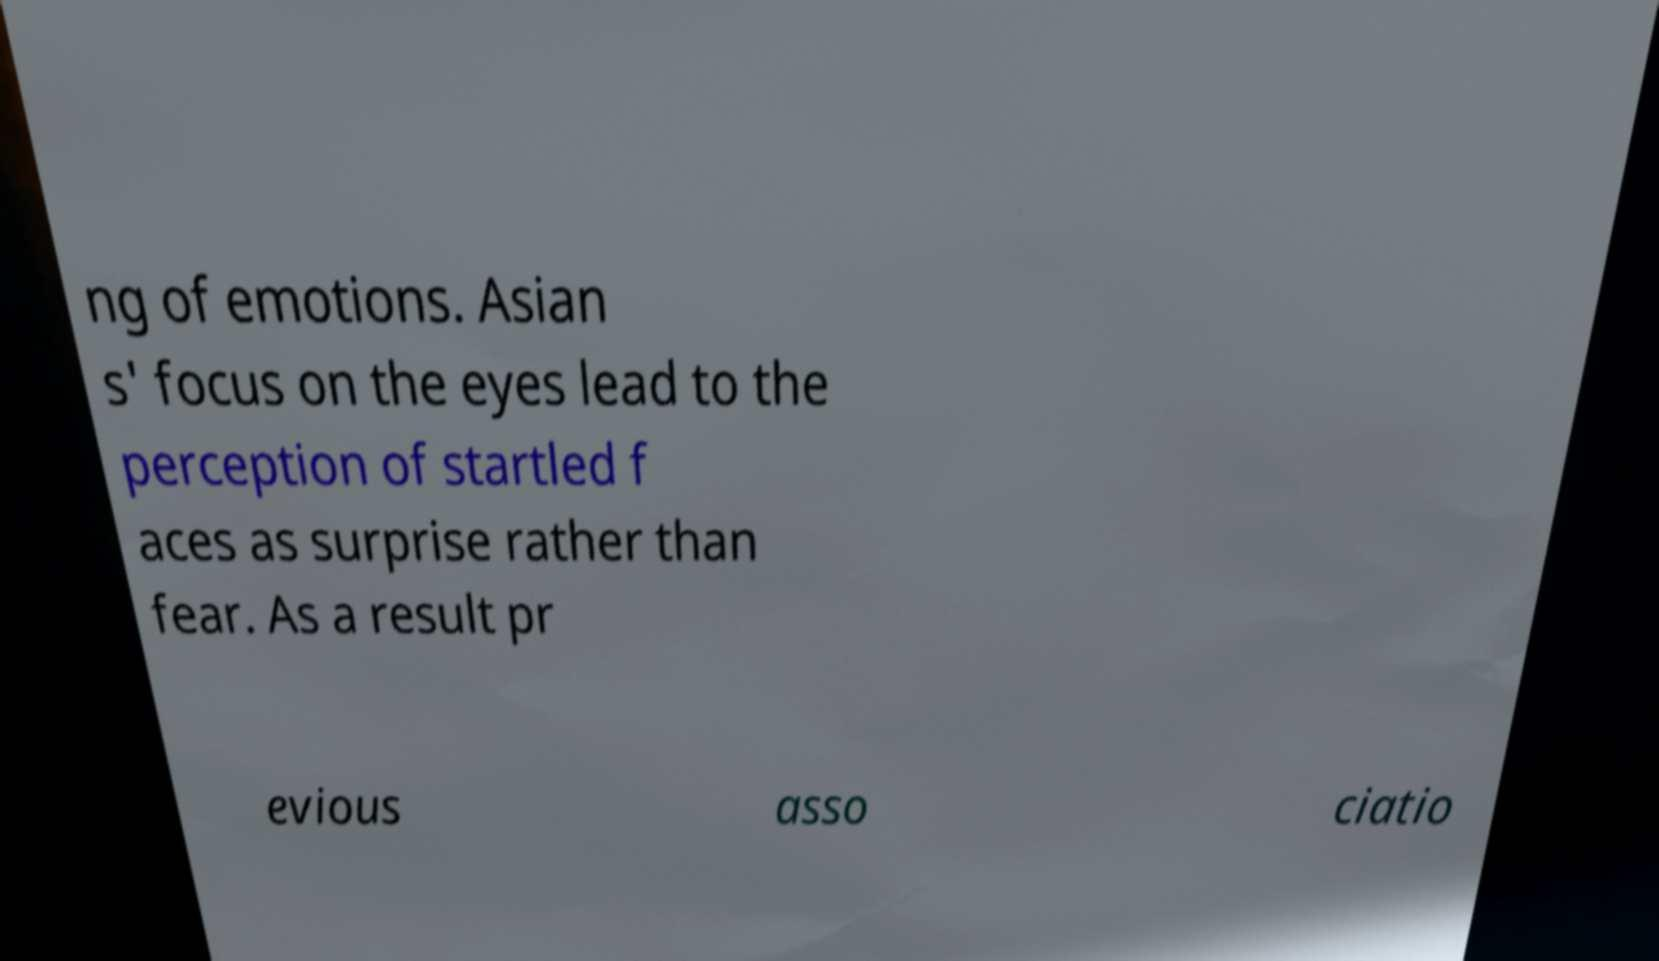What messages or text are displayed in this image? I need them in a readable, typed format. ng of emotions. Asian s' focus on the eyes lead to the perception of startled f aces as surprise rather than fear. As a result pr evious asso ciatio 